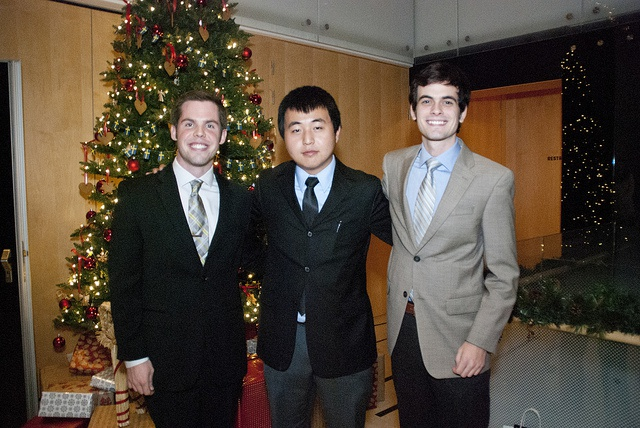Describe the objects in this image and their specific colors. I can see people in maroon, black, lightgray, darkgray, and pink tones, people in maroon, darkgray, black, gray, and lightgray tones, people in maroon, black, tan, lavender, and gray tones, tie in maroon, lightgray, and darkgray tones, and tie in maroon, darkgray, lightgray, and gray tones in this image. 